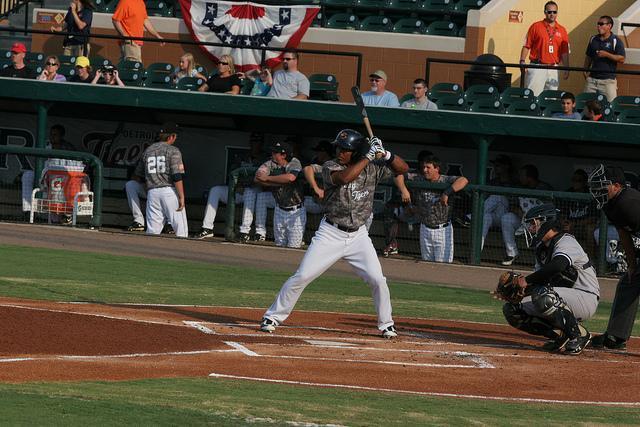How many people are visible?
Give a very brief answer. 5. How many bus riders are leaning out of a bus window?
Give a very brief answer. 0. 